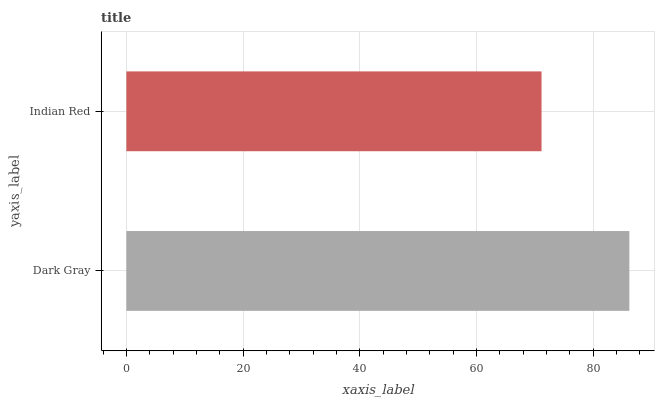Is Indian Red the minimum?
Answer yes or no. Yes. Is Dark Gray the maximum?
Answer yes or no. Yes. Is Indian Red the maximum?
Answer yes or no. No. Is Dark Gray greater than Indian Red?
Answer yes or no. Yes. Is Indian Red less than Dark Gray?
Answer yes or no. Yes. Is Indian Red greater than Dark Gray?
Answer yes or no. No. Is Dark Gray less than Indian Red?
Answer yes or no. No. Is Dark Gray the high median?
Answer yes or no. Yes. Is Indian Red the low median?
Answer yes or no. Yes. Is Indian Red the high median?
Answer yes or no. No. Is Dark Gray the low median?
Answer yes or no. No. 